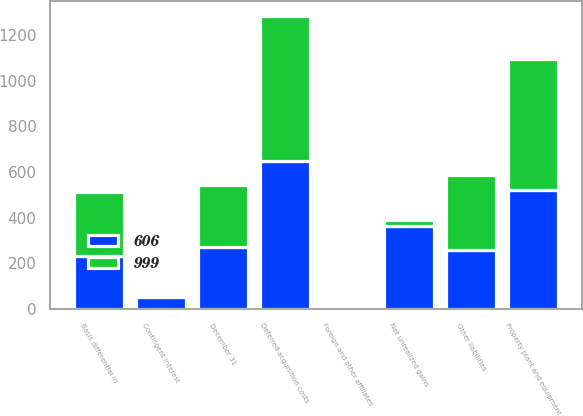Convert chart to OTSL. <chart><loc_0><loc_0><loc_500><loc_500><stacked_bar_chart><ecel><fcel>December 31<fcel>Deferred acquisition costs<fcel>Net unrealized gains<fcel>Property plant and equipment<fcel>Foreign and other affiliates<fcel>Basis differential in<fcel>Contingent interest<fcel>Other liabilities<nl><fcel>999<fcel>271.5<fcel>635<fcel>25<fcel>573<fcel>4<fcel>283<fcel>1<fcel>326<nl><fcel>606<fcel>271.5<fcel>648<fcel>364<fcel>522<fcel>11<fcel>231<fcel>53<fcel>260<nl></chart> 